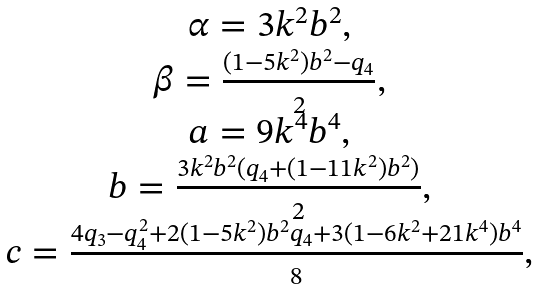Convert formula to latex. <formula><loc_0><loc_0><loc_500><loc_500>\begin{array} { c } \alpha = 3 k ^ { 2 } b ^ { 2 } , \\ \beta = \frac { ( 1 - 5 k ^ { 2 } ) b ^ { 2 } - q _ { 4 } } { 2 } , \\ a = 9 k ^ { 4 } b ^ { 4 } , \\ b = \frac { 3 k ^ { 2 } b ^ { 2 } ( q _ { 4 } + ( 1 - 1 1 k ^ { 2 } ) b ^ { 2 } ) } { 2 } , \\ c = \frac { 4 q _ { 3 } - q _ { 4 } ^ { 2 } + 2 ( 1 - 5 k ^ { 2 } ) b ^ { 2 } q _ { 4 } + 3 ( 1 - 6 k ^ { 2 } + 2 1 k ^ { 4 } ) b ^ { 4 } } { 8 } , \\ \end{array}</formula> 